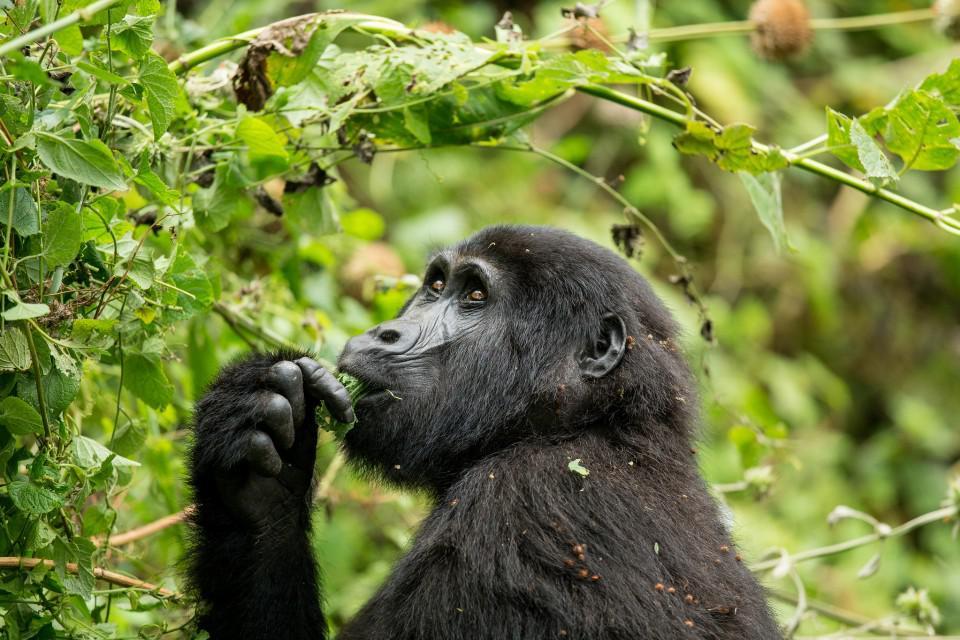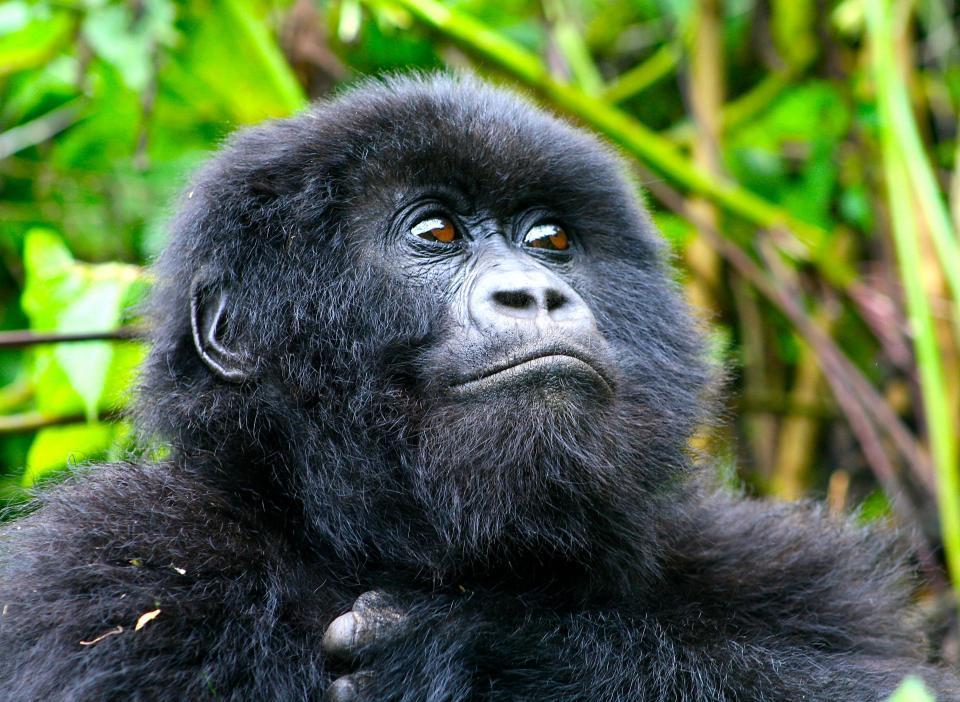The first image is the image on the left, the second image is the image on the right. For the images shown, is this caption "One image has a young ape along with an adult." true? Answer yes or no. No. The first image is the image on the left, the second image is the image on the right. Examine the images to the left and right. Is the description "There is a baby primate with an adult primate." accurate? Answer yes or no. No. 